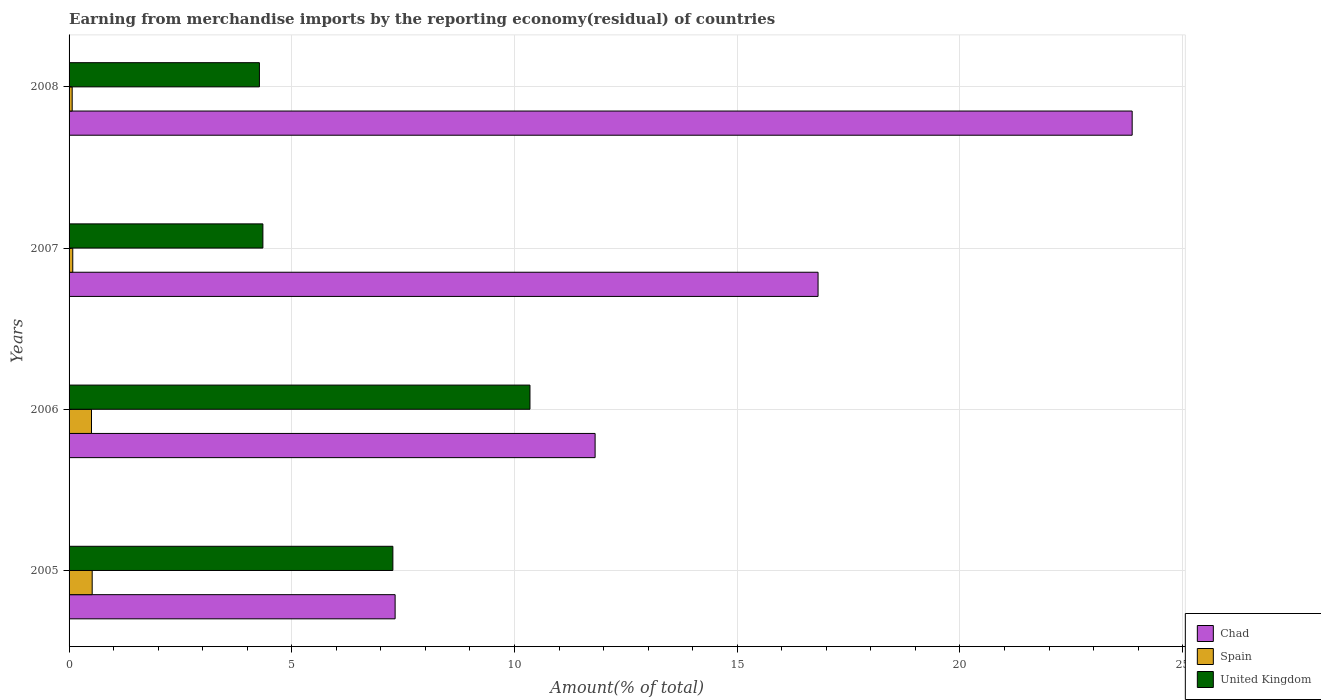How many different coloured bars are there?
Offer a very short reply. 3. Are the number of bars per tick equal to the number of legend labels?
Keep it short and to the point. Yes. Are the number of bars on each tick of the Y-axis equal?
Provide a succinct answer. Yes. What is the label of the 3rd group of bars from the top?
Your answer should be compact. 2006. In how many cases, is the number of bars for a given year not equal to the number of legend labels?
Offer a very short reply. 0. What is the percentage of amount earned from merchandise imports in Chad in 2008?
Your answer should be compact. 23.87. Across all years, what is the maximum percentage of amount earned from merchandise imports in Spain?
Keep it short and to the point. 0.52. Across all years, what is the minimum percentage of amount earned from merchandise imports in United Kingdom?
Provide a succinct answer. 4.27. What is the total percentage of amount earned from merchandise imports in United Kingdom in the graph?
Offer a terse response. 26.24. What is the difference between the percentage of amount earned from merchandise imports in United Kingdom in 2005 and that in 2008?
Your answer should be very brief. 3. What is the difference between the percentage of amount earned from merchandise imports in United Kingdom in 2005 and the percentage of amount earned from merchandise imports in Spain in 2008?
Ensure brevity in your answer.  7.2. What is the average percentage of amount earned from merchandise imports in Spain per year?
Keep it short and to the point. 0.29. In the year 2007, what is the difference between the percentage of amount earned from merchandise imports in Chad and percentage of amount earned from merchandise imports in United Kingdom?
Keep it short and to the point. 12.46. What is the ratio of the percentage of amount earned from merchandise imports in Spain in 2005 to that in 2007?
Offer a terse response. 6.26. Is the percentage of amount earned from merchandise imports in Chad in 2005 less than that in 2006?
Keep it short and to the point. Yes. Is the difference between the percentage of amount earned from merchandise imports in Chad in 2007 and 2008 greater than the difference between the percentage of amount earned from merchandise imports in United Kingdom in 2007 and 2008?
Make the answer very short. No. What is the difference between the highest and the second highest percentage of amount earned from merchandise imports in Spain?
Your answer should be compact. 0.02. What is the difference between the highest and the lowest percentage of amount earned from merchandise imports in Chad?
Ensure brevity in your answer.  16.55. In how many years, is the percentage of amount earned from merchandise imports in United Kingdom greater than the average percentage of amount earned from merchandise imports in United Kingdom taken over all years?
Offer a terse response. 2. Is the sum of the percentage of amount earned from merchandise imports in Chad in 2005 and 2007 greater than the maximum percentage of amount earned from merchandise imports in United Kingdom across all years?
Your answer should be compact. Yes. What does the 3rd bar from the top in 2007 represents?
Your answer should be compact. Chad. What does the 3rd bar from the bottom in 2007 represents?
Provide a succinct answer. United Kingdom. Are all the bars in the graph horizontal?
Provide a short and direct response. Yes. How many years are there in the graph?
Provide a succinct answer. 4. What is the difference between two consecutive major ticks on the X-axis?
Give a very brief answer. 5. Are the values on the major ticks of X-axis written in scientific E-notation?
Your answer should be very brief. No. Does the graph contain any zero values?
Make the answer very short. No. Does the graph contain grids?
Provide a short and direct response. Yes. What is the title of the graph?
Your answer should be very brief. Earning from merchandise imports by the reporting economy(residual) of countries. What is the label or title of the X-axis?
Provide a short and direct response. Amount(% of total). What is the Amount(% of total) in Chad in 2005?
Give a very brief answer. 7.32. What is the Amount(% of total) in Spain in 2005?
Your answer should be very brief. 0.52. What is the Amount(% of total) in United Kingdom in 2005?
Your response must be concise. 7.27. What is the Amount(% of total) of Chad in 2006?
Your answer should be very brief. 11.81. What is the Amount(% of total) in Spain in 2006?
Your answer should be very brief. 0.5. What is the Amount(% of total) of United Kingdom in 2006?
Provide a succinct answer. 10.35. What is the Amount(% of total) of Chad in 2007?
Provide a succinct answer. 16.82. What is the Amount(% of total) of Spain in 2007?
Make the answer very short. 0.08. What is the Amount(% of total) of United Kingdom in 2007?
Ensure brevity in your answer.  4.35. What is the Amount(% of total) of Chad in 2008?
Your answer should be compact. 23.87. What is the Amount(% of total) in Spain in 2008?
Offer a terse response. 0.07. What is the Amount(% of total) in United Kingdom in 2008?
Your answer should be very brief. 4.27. Across all years, what is the maximum Amount(% of total) of Chad?
Provide a succinct answer. 23.87. Across all years, what is the maximum Amount(% of total) in Spain?
Keep it short and to the point. 0.52. Across all years, what is the maximum Amount(% of total) in United Kingdom?
Provide a short and direct response. 10.35. Across all years, what is the minimum Amount(% of total) of Chad?
Provide a short and direct response. 7.32. Across all years, what is the minimum Amount(% of total) of Spain?
Keep it short and to the point. 0.07. Across all years, what is the minimum Amount(% of total) in United Kingdom?
Give a very brief answer. 4.27. What is the total Amount(% of total) of Chad in the graph?
Make the answer very short. 59.81. What is the total Amount(% of total) of Spain in the graph?
Make the answer very short. 1.18. What is the total Amount(% of total) of United Kingdom in the graph?
Your response must be concise. 26.24. What is the difference between the Amount(% of total) in Chad in 2005 and that in 2006?
Your answer should be very brief. -4.49. What is the difference between the Amount(% of total) in Spain in 2005 and that in 2006?
Offer a very short reply. 0.02. What is the difference between the Amount(% of total) of United Kingdom in 2005 and that in 2006?
Your answer should be very brief. -3.08. What is the difference between the Amount(% of total) of Chad in 2005 and that in 2007?
Offer a terse response. -9.5. What is the difference between the Amount(% of total) in Spain in 2005 and that in 2007?
Provide a short and direct response. 0.44. What is the difference between the Amount(% of total) of United Kingdom in 2005 and that in 2007?
Offer a very short reply. 2.92. What is the difference between the Amount(% of total) in Chad in 2005 and that in 2008?
Ensure brevity in your answer.  -16.55. What is the difference between the Amount(% of total) of Spain in 2005 and that in 2008?
Ensure brevity in your answer.  0.45. What is the difference between the Amount(% of total) in United Kingdom in 2005 and that in 2008?
Offer a very short reply. 3. What is the difference between the Amount(% of total) of Chad in 2006 and that in 2007?
Give a very brief answer. -5.01. What is the difference between the Amount(% of total) of Spain in 2006 and that in 2007?
Give a very brief answer. 0.42. What is the difference between the Amount(% of total) of United Kingdom in 2006 and that in 2007?
Provide a succinct answer. 6. What is the difference between the Amount(% of total) in Chad in 2006 and that in 2008?
Ensure brevity in your answer.  -12.06. What is the difference between the Amount(% of total) of Spain in 2006 and that in 2008?
Ensure brevity in your answer.  0.43. What is the difference between the Amount(% of total) in United Kingdom in 2006 and that in 2008?
Offer a terse response. 6.07. What is the difference between the Amount(% of total) of Chad in 2007 and that in 2008?
Your response must be concise. -7.05. What is the difference between the Amount(% of total) of Spain in 2007 and that in 2008?
Provide a succinct answer. 0.01. What is the difference between the Amount(% of total) in United Kingdom in 2007 and that in 2008?
Your response must be concise. 0.08. What is the difference between the Amount(% of total) in Chad in 2005 and the Amount(% of total) in Spain in 2006?
Offer a very short reply. 6.82. What is the difference between the Amount(% of total) of Chad in 2005 and the Amount(% of total) of United Kingdom in 2006?
Your response must be concise. -3.03. What is the difference between the Amount(% of total) in Spain in 2005 and the Amount(% of total) in United Kingdom in 2006?
Your answer should be compact. -9.83. What is the difference between the Amount(% of total) of Chad in 2005 and the Amount(% of total) of Spain in 2007?
Keep it short and to the point. 7.24. What is the difference between the Amount(% of total) of Chad in 2005 and the Amount(% of total) of United Kingdom in 2007?
Provide a succinct answer. 2.97. What is the difference between the Amount(% of total) in Spain in 2005 and the Amount(% of total) in United Kingdom in 2007?
Provide a short and direct response. -3.83. What is the difference between the Amount(% of total) of Chad in 2005 and the Amount(% of total) of Spain in 2008?
Offer a terse response. 7.25. What is the difference between the Amount(% of total) of Chad in 2005 and the Amount(% of total) of United Kingdom in 2008?
Offer a very short reply. 3.05. What is the difference between the Amount(% of total) in Spain in 2005 and the Amount(% of total) in United Kingdom in 2008?
Keep it short and to the point. -3.75. What is the difference between the Amount(% of total) in Chad in 2006 and the Amount(% of total) in Spain in 2007?
Ensure brevity in your answer.  11.73. What is the difference between the Amount(% of total) of Chad in 2006 and the Amount(% of total) of United Kingdom in 2007?
Your response must be concise. 7.46. What is the difference between the Amount(% of total) in Spain in 2006 and the Amount(% of total) in United Kingdom in 2007?
Offer a very short reply. -3.85. What is the difference between the Amount(% of total) of Chad in 2006 and the Amount(% of total) of Spain in 2008?
Offer a very short reply. 11.74. What is the difference between the Amount(% of total) in Chad in 2006 and the Amount(% of total) in United Kingdom in 2008?
Provide a succinct answer. 7.54. What is the difference between the Amount(% of total) of Spain in 2006 and the Amount(% of total) of United Kingdom in 2008?
Provide a short and direct response. -3.77. What is the difference between the Amount(% of total) of Chad in 2007 and the Amount(% of total) of Spain in 2008?
Offer a very short reply. 16.75. What is the difference between the Amount(% of total) of Chad in 2007 and the Amount(% of total) of United Kingdom in 2008?
Your response must be concise. 12.54. What is the difference between the Amount(% of total) of Spain in 2007 and the Amount(% of total) of United Kingdom in 2008?
Make the answer very short. -4.19. What is the average Amount(% of total) of Chad per year?
Make the answer very short. 14.95. What is the average Amount(% of total) in Spain per year?
Your response must be concise. 0.29. What is the average Amount(% of total) of United Kingdom per year?
Keep it short and to the point. 6.56. In the year 2005, what is the difference between the Amount(% of total) in Chad and Amount(% of total) in Spain?
Your answer should be very brief. 6.8. In the year 2005, what is the difference between the Amount(% of total) of Chad and Amount(% of total) of United Kingdom?
Keep it short and to the point. 0.05. In the year 2005, what is the difference between the Amount(% of total) in Spain and Amount(% of total) in United Kingdom?
Your answer should be very brief. -6.75. In the year 2006, what is the difference between the Amount(% of total) in Chad and Amount(% of total) in Spain?
Your answer should be very brief. 11.31. In the year 2006, what is the difference between the Amount(% of total) in Chad and Amount(% of total) in United Kingdom?
Your response must be concise. 1.46. In the year 2006, what is the difference between the Amount(% of total) in Spain and Amount(% of total) in United Kingdom?
Your answer should be compact. -9.84. In the year 2007, what is the difference between the Amount(% of total) of Chad and Amount(% of total) of Spain?
Provide a succinct answer. 16.73. In the year 2007, what is the difference between the Amount(% of total) of Chad and Amount(% of total) of United Kingdom?
Provide a succinct answer. 12.46. In the year 2007, what is the difference between the Amount(% of total) in Spain and Amount(% of total) in United Kingdom?
Offer a very short reply. -4.27. In the year 2008, what is the difference between the Amount(% of total) in Chad and Amount(% of total) in Spain?
Provide a succinct answer. 23.8. In the year 2008, what is the difference between the Amount(% of total) in Chad and Amount(% of total) in United Kingdom?
Your response must be concise. 19.59. In the year 2008, what is the difference between the Amount(% of total) of Spain and Amount(% of total) of United Kingdom?
Make the answer very short. -4.2. What is the ratio of the Amount(% of total) in Chad in 2005 to that in 2006?
Make the answer very short. 0.62. What is the ratio of the Amount(% of total) in Spain in 2005 to that in 2006?
Your answer should be compact. 1.03. What is the ratio of the Amount(% of total) of United Kingdom in 2005 to that in 2006?
Provide a succinct answer. 0.7. What is the ratio of the Amount(% of total) of Chad in 2005 to that in 2007?
Offer a very short reply. 0.44. What is the ratio of the Amount(% of total) of Spain in 2005 to that in 2007?
Make the answer very short. 6.26. What is the ratio of the Amount(% of total) of United Kingdom in 2005 to that in 2007?
Your answer should be very brief. 1.67. What is the ratio of the Amount(% of total) in Chad in 2005 to that in 2008?
Offer a terse response. 0.31. What is the ratio of the Amount(% of total) in Spain in 2005 to that in 2008?
Your response must be concise. 7.43. What is the ratio of the Amount(% of total) of United Kingdom in 2005 to that in 2008?
Offer a terse response. 1.7. What is the ratio of the Amount(% of total) of Chad in 2006 to that in 2007?
Your answer should be compact. 0.7. What is the ratio of the Amount(% of total) of Spain in 2006 to that in 2007?
Keep it short and to the point. 6.07. What is the ratio of the Amount(% of total) of United Kingdom in 2006 to that in 2007?
Provide a succinct answer. 2.38. What is the ratio of the Amount(% of total) in Chad in 2006 to that in 2008?
Ensure brevity in your answer.  0.49. What is the ratio of the Amount(% of total) of Spain in 2006 to that in 2008?
Your answer should be very brief. 7.2. What is the ratio of the Amount(% of total) of United Kingdom in 2006 to that in 2008?
Give a very brief answer. 2.42. What is the ratio of the Amount(% of total) of Chad in 2007 to that in 2008?
Your response must be concise. 0.7. What is the ratio of the Amount(% of total) in Spain in 2007 to that in 2008?
Offer a very short reply. 1.19. What is the ratio of the Amount(% of total) in United Kingdom in 2007 to that in 2008?
Your response must be concise. 1.02. What is the difference between the highest and the second highest Amount(% of total) of Chad?
Your answer should be very brief. 7.05. What is the difference between the highest and the second highest Amount(% of total) in Spain?
Make the answer very short. 0.02. What is the difference between the highest and the second highest Amount(% of total) of United Kingdom?
Keep it short and to the point. 3.08. What is the difference between the highest and the lowest Amount(% of total) of Chad?
Your response must be concise. 16.55. What is the difference between the highest and the lowest Amount(% of total) in Spain?
Your answer should be very brief. 0.45. What is the difference between the highest and the lowest Amount(% of total) of United Kingdom?
Ensure brevity in your answer.  6.07. 